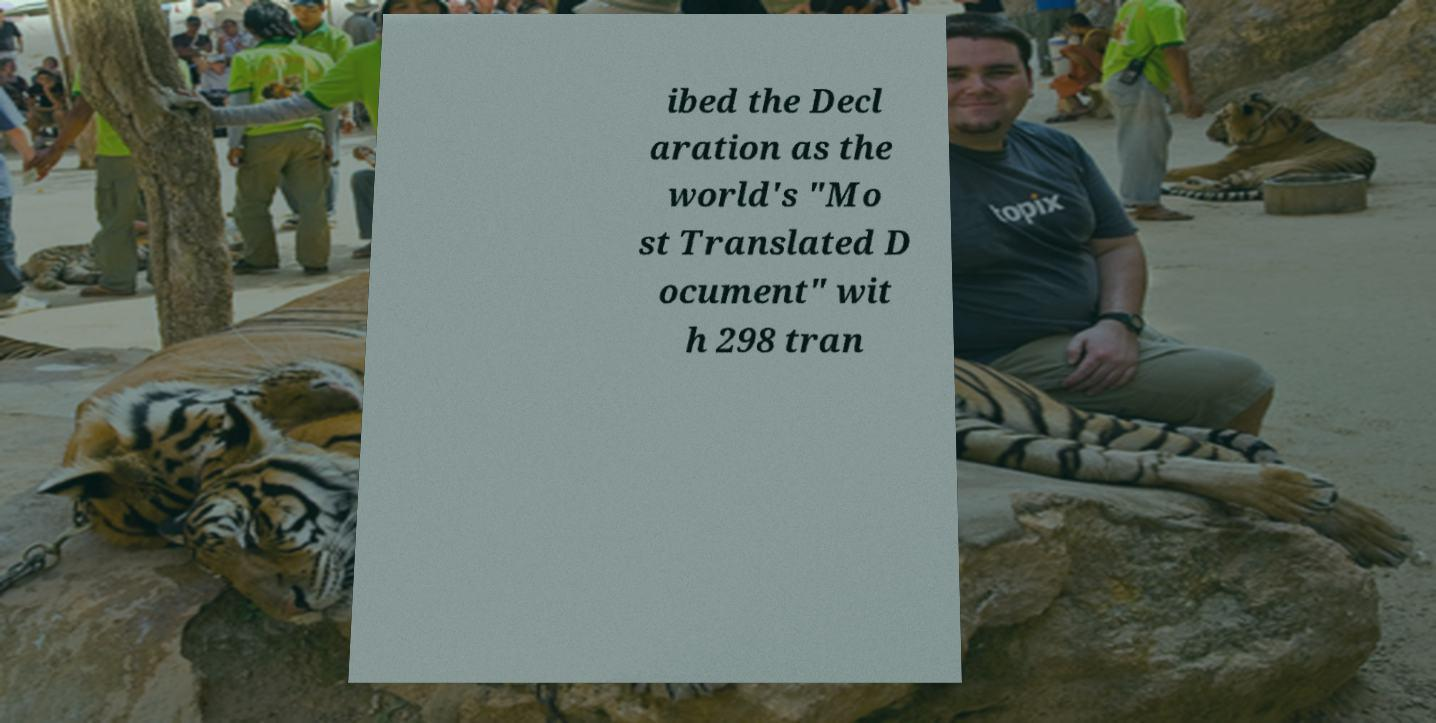Please identify and transcribe the text found in this image. ibed the Decl aration as the world's "Mo st Translated D ocument" wit h 298 tran 